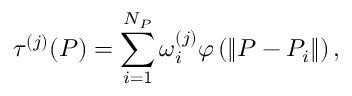Convert formula to latex. <formula><loc_0><loc_0><loc_500><loc_500>\tau ^ { ( j ) } ( P ) = \sum _ { i = 1 } ^ { N _ { P } } \omega _ { i } ^ { ( j ) } \varphi \left ( \left \| P - P _ { i } \right \| \right ) ,</formula> 